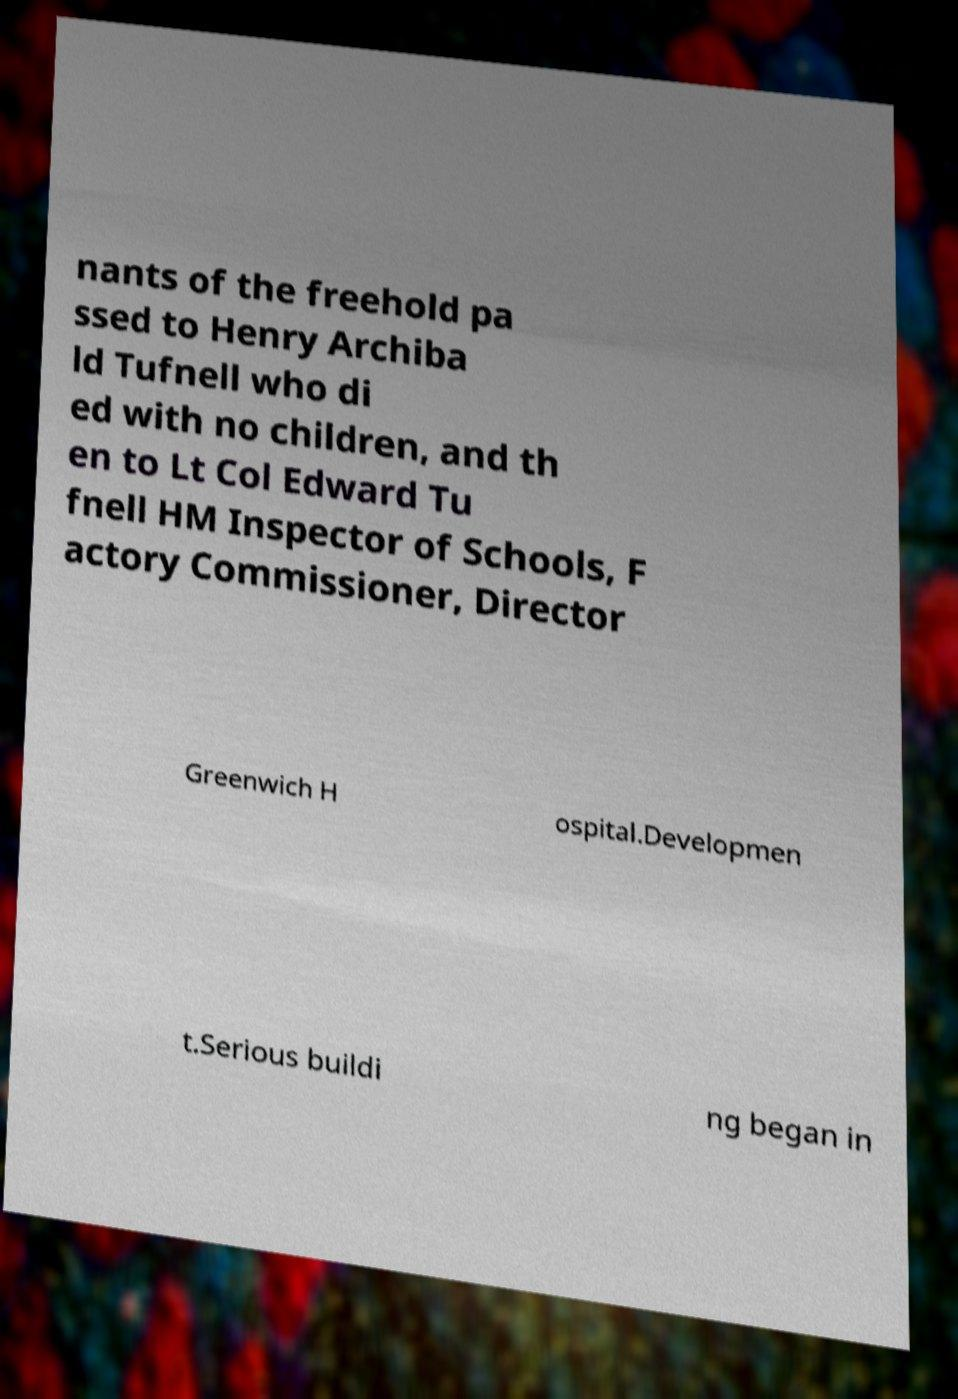I need the written content from this picture converted into text. Can you do that? nants of the freehold pa ssed to Henry Archiba ld Tufnell who di ed with no children, and th en to Lt Col Edward Tu fnell HM Inspector of Schools, F actory Commissioner, Director Greenwich H ospital.Developmen t.Serious buildi ng began in 